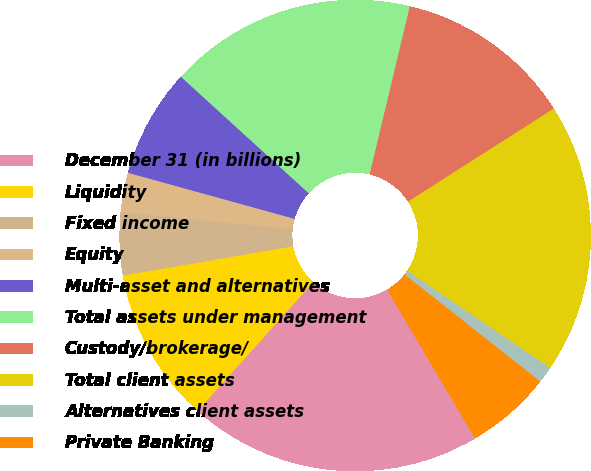Convert chart to OTSL. <chart><loc_0><loc_0><loc_500><loc_500><pie_chart><fcel>December 31 (in billions)<fcel>Liquidity<fcel>Fixed income<fcel>Equity<fcel>Multi-asset and alternatives<fcel>Total assets under management<fcel>Custody/brokerage/<fcel>Total client assets<fcel>Alternatives client assets<fcel>Private Banking<nl><fcel>20.14%<fcel>10.63%<fcel>4.3%<fcel>2.71%<fcel>7.47%<fcel>16.97%<fcel>12.22%<fcel>18.55%<fcel>1.13%<fcel>5.88%<nl></chart> 